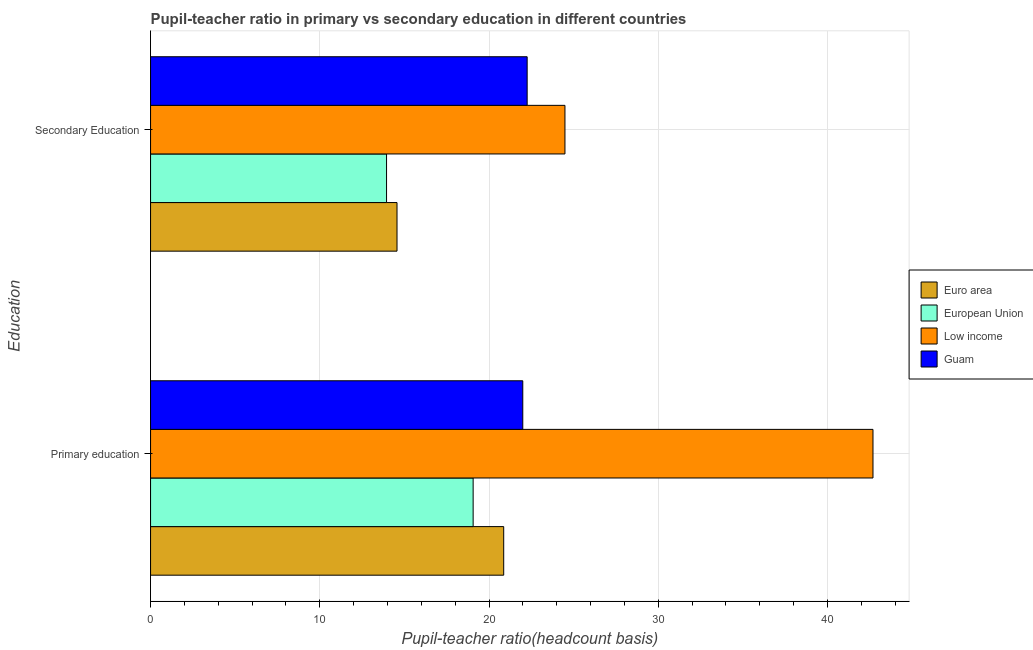How many groups of bars are there?
Offer a very short reply. 2. What is the label of the 2nd group of bars from the top?
Your answer should be very brief. Primary education. What is the pupil teacher ratio on secondary education in Low income?
Ensure brevity in your answer.  24.49. Across all countries, what is the maximum pupil-teacher ratio in primary education?
Keep it short and to the point. 42.69. Across all countries, what is the minimum pupil teacher ratio on secondary education?
Provide a short and direct response. 13.95. What is the total pupil-teacher ratio in primary education in the graph?
Give a very brief answer. 104.62. What is the difference between the pupil teacher ratio on secondary education in Euro area and that in European Union?
Keep it short and to the point. 0.62. What is the difference between the pupil teacher ratio on secondary education in Euro area and the pupil-teacher ratio in primary education in Low income?
Offer a terse response. -28.13. What is the average pupil-teacher ratio in primary education per country?
Your answer should be very brief. 26.16. What is the difference between the pupil teacher ratio on secondary education and pupil-teacher ratio in primary education in European Union?
Give a very brief answer. -5.12. In how many countries, is the pupil-teacher ratio in primary education greater than 4 ?
Make the answer very short. 4. What is the ratio of the pupil teacher ratio on secondary education in Euro area to that in Low income?
Your response must be concise. 0.59. In how many countries, is the pupil-teacher ratio in primary education greater than the average pupil-teacher ratio in primary education taken over all countries?
Offer a terse response. 1. What does the 2nd bar from the bottom in Secondary Education represents?
Make the answer very short. European Union. How many bars are there?
Ensure brevity in your answer.  8. Are all the bars in the graph horizontal?
Your answer should be compact. Yes. Are the values on the major ticks of X-axis written in scientific E-notation?
Your answer should be very brief. No. Does the graph contain grids?
Offer a terse response. Yes. How many legend labels are there?
Your answer should be compact. 4. What is the title of the graph?
Your response must be concise. Pupil-teacher ratio in primary vs secondary education in different countries. What is the label or title of the X-axis?
Give a very brief answer. Pupil-teacher ratio(headcount basis). What is the label or title of the Y-axis?
Make the answer very short. Education. What is the Pupil-teacher ratio(headcount basis) in Euro area in Primary education?
Keep it short and to the point. 20.87. What is the Pupil-teacher ratio(headcount basis) of European Union in Primary education?
Provide a short and direct response. 19.06. What is the Pupil-teacher ratio(headcount basis) in Low income in Primary education?
Ensure brevity in your answer.  42.69. What is the Pupil-teacher ratio(headcount basis) in Guam in Primary education?
Keep it short and to the point. 22. What is the Pupil-teacher ratio(headcount basis) in Euro area in Secondary Education?
Make the answer very short. 14.56. What is the Pupil-teacher ratio(headcount basis) of European Union in Secondary Education?
Ensure brevity in your answer.  13.95. What is the Pupil-teacher ratio(headcount basis) in Low income in Secondary Education?
Keep it short and to the point. 24.49. What is the Pupil-teacher ratio(headcount basis) in Guam in Secondary Education?
Ensure brevity in your answer.  22.26. Across all Education, what is the maximum Pupil-teacher ratio(headcount basis) of Euro area?
Provide a short and direct response. 20.87. Across all Education, what is the maximum Pupil-teacher ratio(headcount basis) of European Union?
Offer a very short reply. 19.06. Across all Education, what is the maximum Pupil-teacher ratio(headcount basis) in Low income?
Your answer should be very brief. 42.69. Across all Education, what is the maximum Pupil-teacher ratio(headcount basis) in Guam?
Keep it short and to the point. 22.26. Across all Education, what is the minimum Pupil-teacher ratio(headcount basis) in Euro area?
Ensure brevity in your answer.  14.56. Across all Education, what is the minimum Pupil-teacher ratio(headcount basis) of European Union?
Offer a very short reply. 13.95. Across all Education, what is the minimum Pupil-teacher ratio(headcount basis) of Low income?
Your answer should be very brief. 24.49. Across all Education, what is the minimum Pupil-teacher ratio(headcount basis) in Guam?
Give a very brief answer. 22. What is the total Pupil-teacher ratio(headcount basis) of Euro area in the graph?
Keep it short and to the point. 35.43. What is the total Pupil-teacher ratio(headcount basis) in European Union in the graph?
Provide a succinct answer. 33.01. What is the total Pupil-teacher ratio(headcount basis) in Low income in the graph?
Make the answer very short. 67.18. What is the total Pupil-teacher ratio(headcount basis) of Guam in the graph?
Make the answer very short. 44.25. What is the difference between the Pupil-teacher ratio(headcount basis) of Euro area in Primary education and that in Secondary Education?
Offer a terse response. 6.31. What is the difference between the Pupil-teacher ratio(headcount basis) of European Union in Primary education and that in Secondary Education?
Offer a very short reply. 5.12. What is the difference between the Pupil-teacher ratio(headcount basis) in Low income in Primary education and that in Secondary Education?
Give a very brief answer. 18.2. What is the difference between the Pupil-teacher ratio(headcount basis) in Guam in Primary education and that in Secondary Education?
Make the answer very short. -0.26. What is the difference between the Pupil-teacher ratio(headcount basis) in Euro area in Primary education and the Pupil-teacher ratio(headcount basis) in European Union in Secondary Education?
Offer a terse response. 6.92. What is the difference between the Pupil-teacher ratio(headcount basis) of Euro area in Primary education and the Pupil-teacher ratio(headcount basis) of Low income in Secondary Education?
Your answer should be compact. -3.62. What is the difference between the Pupil-teacher ratio(headcount basis) in Euro area in Primary education and the Pupil-teacher ratio(headcount basis) in Guam in Secondary Education?
Keep it short and to the point. -1.39. What is the difference between the Pupil-teacher ratio(headcount basis) in European Union in Primary education and the Pupil-teacher ratio(headcount basis) in Low income in Secondary Education?
Make the answer very short. -5.43. What is the difference between the Pupil-teacher ratio(headcount basis) in European Union in Primary education and the Pupil-teacher ratio(headcount basis) in Guam in Secondary Education?
Ensure brevity in your answer.  -3.19. What is the difference between the Pupil-teacher ratio(headcount basis) in Low income in Primary education and the Pupil-teacher ratio(headcount basis) in Guam in Secondary Education?
Your answer should be very brief. 20.44. What is the average Pupil-teacher ratio(headcount basis) of Euro area per Education?
Give a very brief answer. 17.72. What is the average Pupil-teacher ratio(headcount basis) of European Union per Education?
Your answer should be compact. 16.5. What is the average Pupil-teacher ratio(headcount basis) in Low income per Education?
Keep it short and to the point. 33.59. What is the average Pupil-teacher ratio(headcount basis) in Guam per Education?
Provide a succinct answer. 22.13. What is the difference between the Pupil-teacher ratio(headcount basis) of Euro area and Pupil-teacher ratio(headcount basis) of European Union in Primary education?
Ensure brevity in your answer.  1.81. What is the difference between the Pupil-teacher ratio(headcount basis) of Euro area and Pupil-teacher ratio(headcount basis) of Low income in Primary education?
Offer a terse response. -21.82. What is the difference between the Pupil-teacher ratio(headcount basis) in Euro area and Pupil-teacher ratio(headcount basis) in Guam in Primary education?
Your answer should be compact. -1.13. What is the difference between the Pupil-teacher ratio(headcount basis) of European Union and Pupil-teacher ratio(headcount basis) of Low income in Primary education?
Give a very brief answer. -23.63. What is the difference between the Pupil-teacher ratio(headcount basis) of European Union and Pupil-teacher ratio(headcount basis) of Guam in Primary education?
Your answer should be compact. -2.93. What is the difference between the Pupil-teacher ratio(headcount basis) of Low income and Pupil-teacher ratio(headcount basis) of Guam in Primary education?
Offer a very short reply. 20.7. What is the difference between the Pupil-teacher ratio(headcount basis) in Euro area and Pupil-teacher ratio(headcount basis) in European Union in Secondary Education?
Offer a terse response. 0.62. What is the difference between the Pupil-teacher ratio(headcount basis) in Euro area and Pupil-teacher ratio(headcount basis) in Low income in Secondary Education?
Keep it short and to the point. -9.92. What is the difference between the Pupil-teacher ratio(headcount basis) in Euro area and Pupil-teacher ratio(headcount basis) in Guam in Secondary Education?
Provide a short and direct response. -7.69. What is the difference between the Pupil-teacher ratio(headcount basis) in European Union and Pupil-teacher ratio(headcount basis) in Low income in Secondary Education?
Offer a terse response. -10.54. What is the difference between the Pupil-teacher ratio(headcount basis) of European Union and Pupil-teacher ratio(headcount basis) of Guam in Secondary Education?
Your answer should be very brief. -8.31. What is the difference between the Pupil-teacher ratio(headcount basis) in Low income and Pupil-teacher ratio(headcount basis) in Guam in Secondary Education?
Make the answer very short. 2.23. What is the ratio of the Pupil-teacher ratio(headcount basis) of Euro area in Primary education to that in Secondary Education?
Your answer should be compact. 1.43. What is the ratio of the Pupil-teacher ratio(headcount basis) in European Union in Primary education to that in Secondary Education?
Offer a terse response. 1.37. What is the ratio of the Pupil-teacher ratio(headcount basis) of Low income in Primary education to that in Secondary Education?
Ensure brevity in your answer.  1.74. What is the ratio of the Pupil-teacher ratio(headcount basis) of Guam in Primary education to that in Secondary Education?
Offer a terse response. 0.99. What is the difference between the highest and the second highest Pupil-teacher ratio(headcount basis) in Euro area?
Your answer should be very brief. 6.31. What is the difference between the highest and the second highest Pupil-teacher ratio(headcount basis) in European Union?
Offer a terse response. 5.12. What is the difference between the highest and the second highest Pupil-teacher ratio(headcount basis) in Low income?
Offer a very short reply. 18.2. What is the difference between the highest and the second highest Pupil-teacher ratio(headcount basis) in Guam?
Give a very brief answer. 0.26. What is the difference between the highest and the lowest Pupil-teacher ratio(headcount basis) in Euro area?
Offer a terse response. 6.31. What is the difference between the highest and the lowest Pupil-teacher ratio(headcount basis) of European Union?
Provide a short and direct response. 5.12. What is the difference between the highest and the lowest Pupil-teacher ratio(headcount basis) of Low income?
Provide a succinct answer. 18.2. What is the difference between the highest and the lowest Pupil-teacher ratio(headcount basis) in Guam?
Provide a succinct answer. 0.26. 